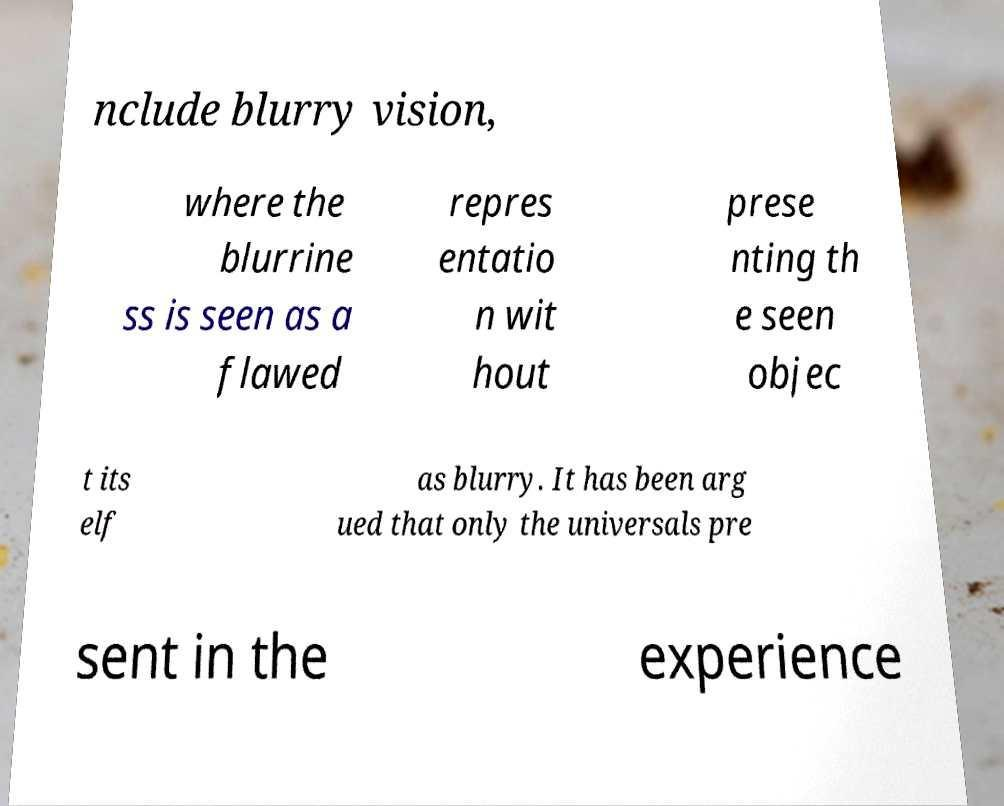What messages or text are displayed in this image? I need them in a readable, typed format. nclude blurry vision, where the blurrine ss is seen as a flawed repres entatio n wit hout prese nting th e seen objec t its elf as blurry. It has been arg ued that only the universals pre sent in the experience 